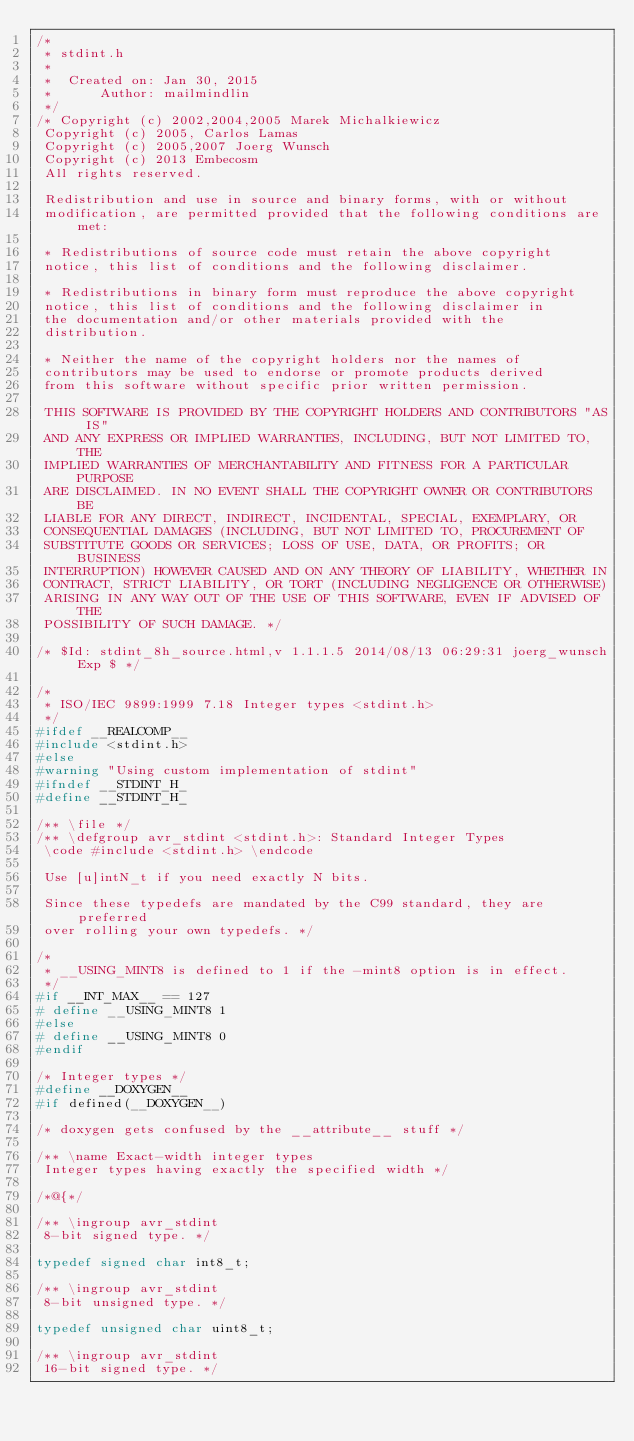<code> <loc_0><loc_0><loc_500><loc_500><_C_>/*
 * stdint.h
 *
 *  Created on: Jan 30, 2015
 *      Author: mailmindlin
 */
/* Copyright (c) 2002,2004,2005 Marek Michalkiewicz
 Copyright (c) 2005, Carlos Lamas
 Copyright (c) 2005,2007 Joerg Wunsch
 Copyright (c) 2013 Embecosm
 All rights reserved.

 Redistribution and use in source and binary forms, with or without
 modification, are permitted provided that the following conditions are met:

 * Redistributions of source code must retain the above copyright
 notice, this list of conditions and the following disclaimer.

 * Redistributions in binary form must reproduce the above copyright
 notice, this list of conditions and the following disclaimer in
 the documentation and/or other materials provided with the
 distribution.

 * Neither the name of the copyright holders nor the names of
 contributors may be used to endorse or promote products derived
 from this software without specific prior written permission.

 THIS SOFTWARE IS PROVIDED BY THE COPYRIGHT HOLDERS AND CONTRIBUTORS "AS IS"
 AND ANY EXPRESS OR IMPLIED WARRANTIES, INCLUDING, BUT NOT LIMITED TO, THE
 IMPLIED WARRANTIES OF MERCHANTABILITY AND FITNESS FOR A PARTICULAR PURPOSE
 ARE DISCLAIMED. IN NO EVENT SHALL THE COPYRIGHT OWNER OR CONTRIBUTORS BE
 LIABLE FOR ANY DIRECT, INDIRECT, INCIDENTAL, SPECIAL, EXEMPLARY, OR
 CONSEQUENTIAL DAMAGES (INCLUDING, BUT NOT LIMITED TO, PROCUREMENT OF
 SUBSTITUTE GOODS OR SERVICES; LOSS OF USE, DATA, OR PROFITS; OR BUSINESS
 INTERRUPTION) HOWEVER CAUSED AND ON ANY THEORY OF LIABILITY, WHETHER IN
 CONTRACT, STRICT LIABILITY, OR TORT (INCLUDING NEGLIGENCE OR OTHERWISE)
 ARISING IN ANY WAY OUT OF THE USE OF THIS SOFTWARE, EVEN IF ADVISED OF THE
 POSSIBILITY OF SUCH DAMAGE. */

/* $Id: stdint_8h_source.html,v 1.1.1.5 2014/08/13 06:29:31 joerg_wunsch Exp $ */

/*
 * ISO/IEC 9899:1999 7.18 Integer types <stdint.h>
 */
#ifdef __REALCOMP__
#include <stdint.h>
#else
#warning "Using custom implementation of stdint"
#ifndef __STDINT_H_
#define __STDINT_H_

/** \file */
/** \defgroup avr_stdint <stdint.h>: Standard Integer Types
 \code #include <stdint.h> \endcode

 Use [u]intN_t if you need exactly N bits.

 Since these typedefs are mandated by the C99 standard, they are preferred
 over rolling your own typedefs. */

/*
 * __USING_MINT8 is defined to 1 if the -mint8 option is in effect.
 */
#if __INT_MAX__ == 127
# define __USING_MINT8 1
#else
# define __USING_MINT8 0
#endif

/* Integer types */
#define __DOXYGEN__
#if defined(__DOXYGEN__)

/* doxygen gets confused by the __attribute__ stuff */

/** \name Exact-width integer types
 Integer types having exactly the specified width */

/*@{*/

/** \ingroup avr_stdint
 8-bit signed type. */

typedef signed char int8_t;

/** \ingroup avr_stdint
 8-bit unsigned type. */

typedef unsigned char uint8_t;

/** \ingroup avr_stdint
 16-bit signed type. */
</code> 